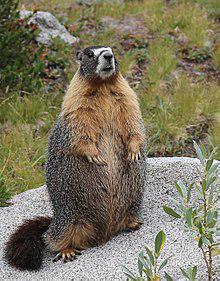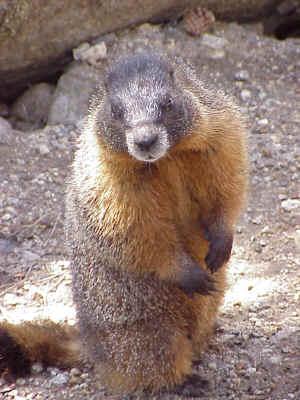The first image is the image on the left, the second image is the image on the right. For the images displayed, is the sentence "There are two marmots standing up on their hind legs" factually correct? Answer yes or no. Yes. 